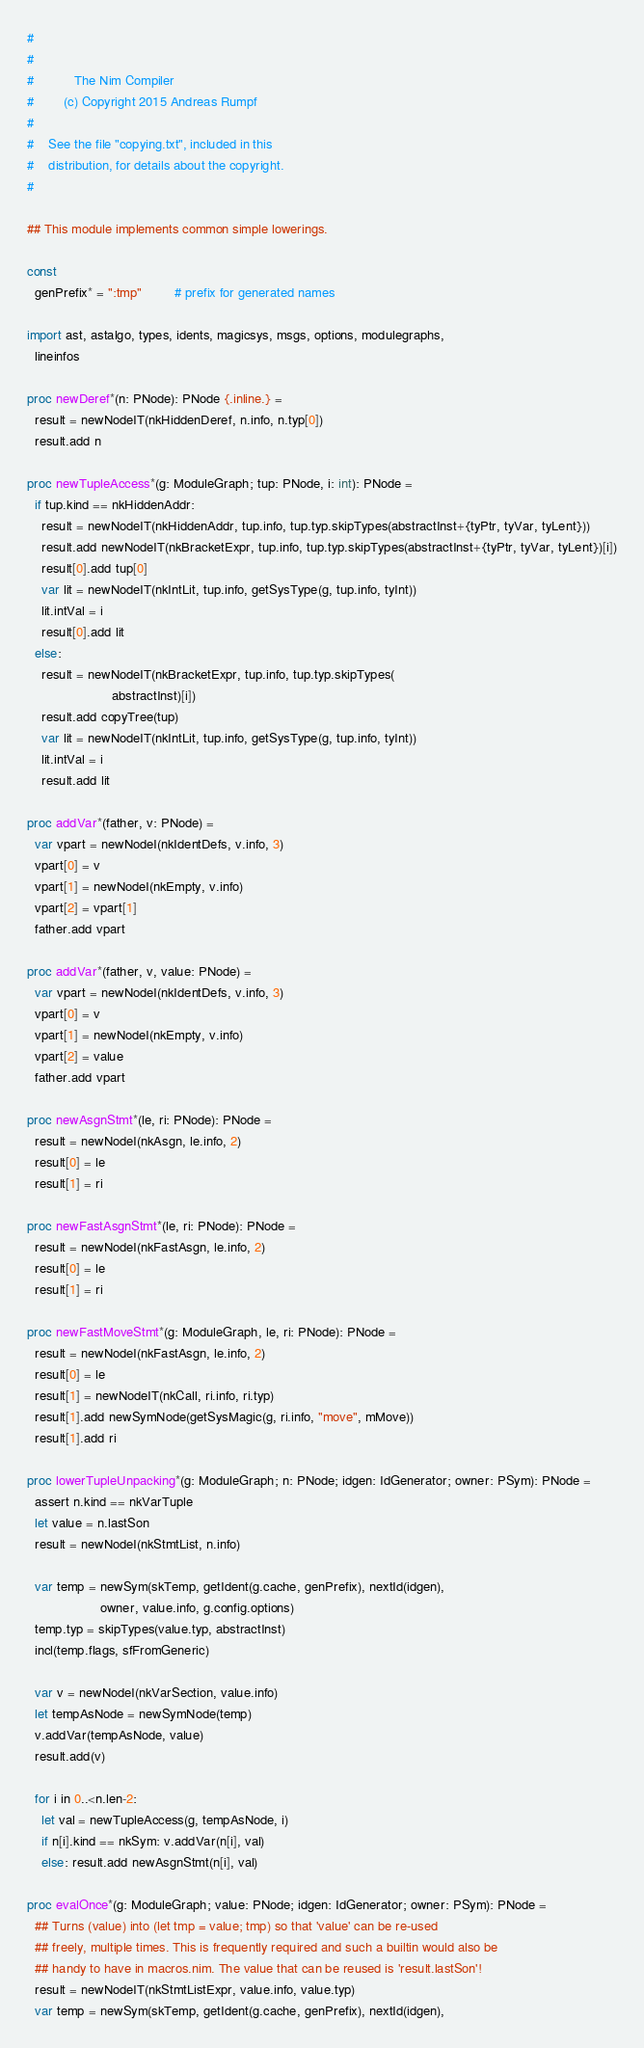<code> <loc_0><loc_0><loc_500><loc_500><_Nim_>#
#
#           The Nim Compiler
#        (c) Copyright 2015 Andreas Rumpf
#
#    See the file "copying.txt", included in this
#    distribution, for details about the copyright.
#

## This module implements common simple lowerings.

const
  genPrefix* = ":tmp"         # prefix for generated names

import ast, astalgo, types, idents, magicsys, msgs, options, modulegraphs,
  lineinfos

proc newDeref*(n: PNode): PNode {.inline.} =
  result = newNodeIT(nkHiddenDeref, n.info, n.typ[0])
  result.add n

proc newTupleAccess*(g: ModuleGraph; tup: PNode, i: int): PNode =
  if tup.kind == nkHiddenAddr:
    result = newNodeIT(nkHiddenAddr, tup.info, tup.typ.skipTypes(abstractInst+{tyPtr, tyVar, tyLent}))
    result.add newNodeIT(nkBracketExpr, tup.info, tup.typ.skipTypes(abstractInst+{tyPtr, tyVar, tyLent})[i])
    result[0].add tup[0]
    var lit = newNodeIT(nkIntLit, tup.info, getSysType(g, tup.info, tyInt))
    lit.intVal = i
    result[0].add lit
  else:
    result = newNodeIT(nkBracketExpr, tup.info, tup.typ.skipTypes(
                       abstractInst)[i])
    result.add copyTree(tup)
    var lit = newNodeIT(nkIntLit, tup.info, getSysType(g, tup.info, tyInt))
    lit.intVal = i
    result.add lit

proc addVar*(father, v: PNode) =
  var vpart = newNodeI(nkIdentDefs, v.info, 3)
  vpart[0] = v
  vpart[1] = newNodeI(nkEmpty, v.info)
  vpart[2] = vpart[1]
  father.add vpart

proc addVar*(father, v, value: PNode) =
  var vpart = newNodeI(nkIdentDefs, v.info, 3)
  vpart[0] = v
  vpart[1] = newNodeI(nkEmpty, v.info)
  vpart[2] = value
  father.add vpart

proc newAsgnStmt*(le, ri: PNode): PNode =
  result = newNodeI(nkAsgn, le.info, 2)
  result[0] = le
  result[1] = ri

proc newFastAsgnStmt*(le, ri: PNode): PNode =
  result = newNodeI(nkFastAsgn, le.info, 2)
  result[0] = le
  result[1] = ri

proc newFastMoveStmt*(g: ModuleGraph, le, ri: PNode): PNode =
  result = newNodeI(nkFastAsgn, le.info, 2)
  result[0] = le
  result[1] = newNodeIT(nkCall, ri.info, ri.typ)
  result[1].add newSymNode(getSysMagic(g, ri.info, "move", mMove))
  result[1].add ri

proc lowerTupleUnpacking*(g: ModuleGraph; n: PNode; idgen: IdGenerator; owner: PSym): PNode =
  assert n.kind == nkVarTuple
  let value = n.lastSon
  result = newNodeI(nkStmtList, n.info)

  var temp = newSym(skTemp, getIdent(g.cache, genPrefix), nextId(idgen),
                    owner, value.info, g.config.options)
  temp.typ = skipTypes(value.typ, abstractInst)
  incl(temp.flags, sfFromGeneric)

  var v = newNodeI(nkVarSection, value.info)
  let tempAsNode = newSymNode(temp)
  v.addVar(tempAsNode, value)
  result.add(v)

  for i in 0..<n.len-2:
    let val = newTupleAccess(g, tempAsNode, i)
    if n[i].kind == nkSym: v.addVar(n[i], val)
    else: result.add newAsgnStmt(n[i], val)

proc evalOnce*(g: ModuleGraph; value: PNode; idgen: IdGenerator; owner: PSym): PNode =
  ## Turns (value) into (let tmp = value; tmp) so that 'value' can be re-used
  ## freely, multiple times. This is frequently required and such a builtin would also be
  ## handy to have in macros.nim. The value that can be reused is 'result.lastSon'!
  result = newNodeIT(nkStmtListExpr, value.info, value.typ)
  var temp = newSym(skTemp, getIdent(g.cache, genPrefix), nextId(idgen),</code> 